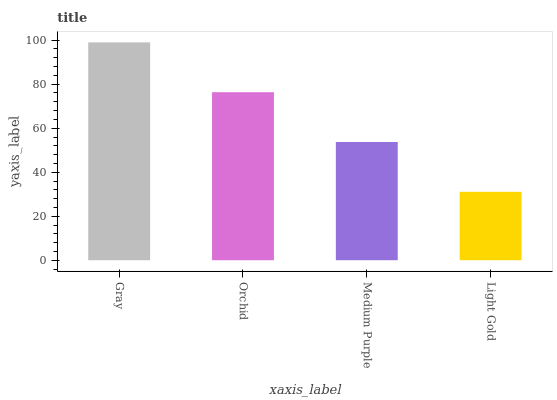Is Light Gold the minimum?
Answer yes or no. Yes. Is Gray the maximum?
Answer yes or no. Yes. Is Orchid the minimum?
Answer yes or no. No. Is Orchid the maximum?
Answer yes or no. No. Is Gray greater than Orchid?
Answer yes or no. Yes. Is Orchid less than Gray?
Answer yes or no. Yes. Is Orchid greater than Gray?
Answer yes or no. No. Is Gray less than Orchid?
Answer yes or no. No. Is Orchid the high median?
Answer yes or no. Yes. Is Medium Purple the low median?
Answer yes or no. Yes. Is Gray the high median?
Answer yes or no. No. Is Gray the low median?
Answer yes or no. No. 